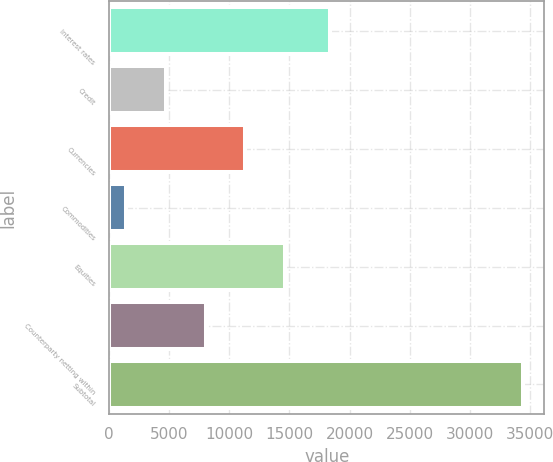Convert chart to OTSL. <chart><loc_0><loc_0><loc_500><loc_500><bar_chart><fcel>Interest rates<fcel>Credit<fcel>Currencies<fcel>Commodities<fcel>Equities<fcel>Counterparty netting within<fcel>Subtotal<nl><fcel>18376<fcel>4721.2<fcel>11333.6<fcel>1415<fcel>14639.8<fcel>8027.4<fcel>34477<nl></chart> 